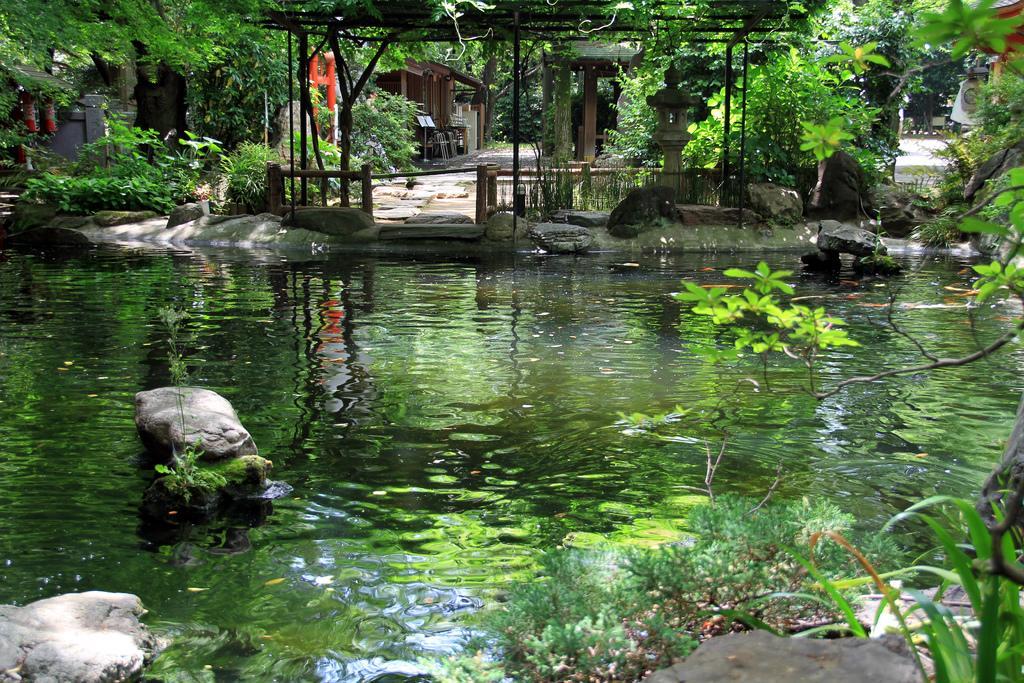Describe this image in one or two sentences. In this image we can see a water body, a group of plants and some stones. On the backside we can see a wooden house with roof, some poles, a fence, a wooden roof and a group of plants. 